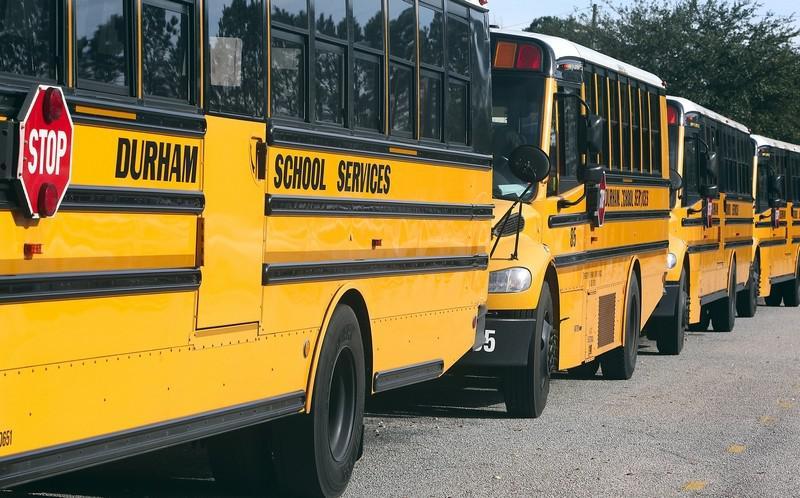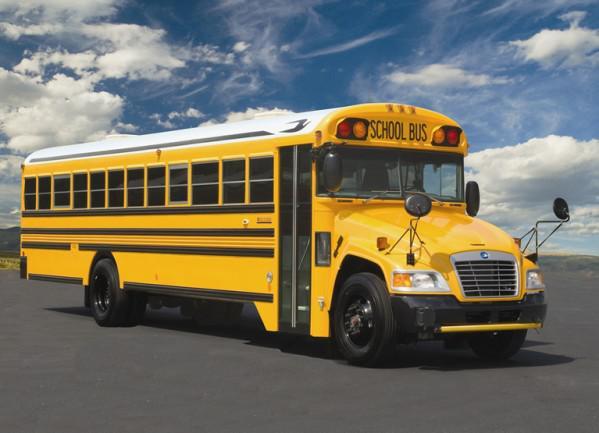The first image is the image on the left, the second image is the image on the right. Considering the images on both sides, is "One image shows a horizontal view of a long bus with an extra door on the side near the middle of the bus." valid? Answer yes or no. No. The first image is the image on the left, the second image is the image on the right. Analyze the images presented: Is the assertion "One bus' passenger door is open." valid? Answer yes or no. No. 